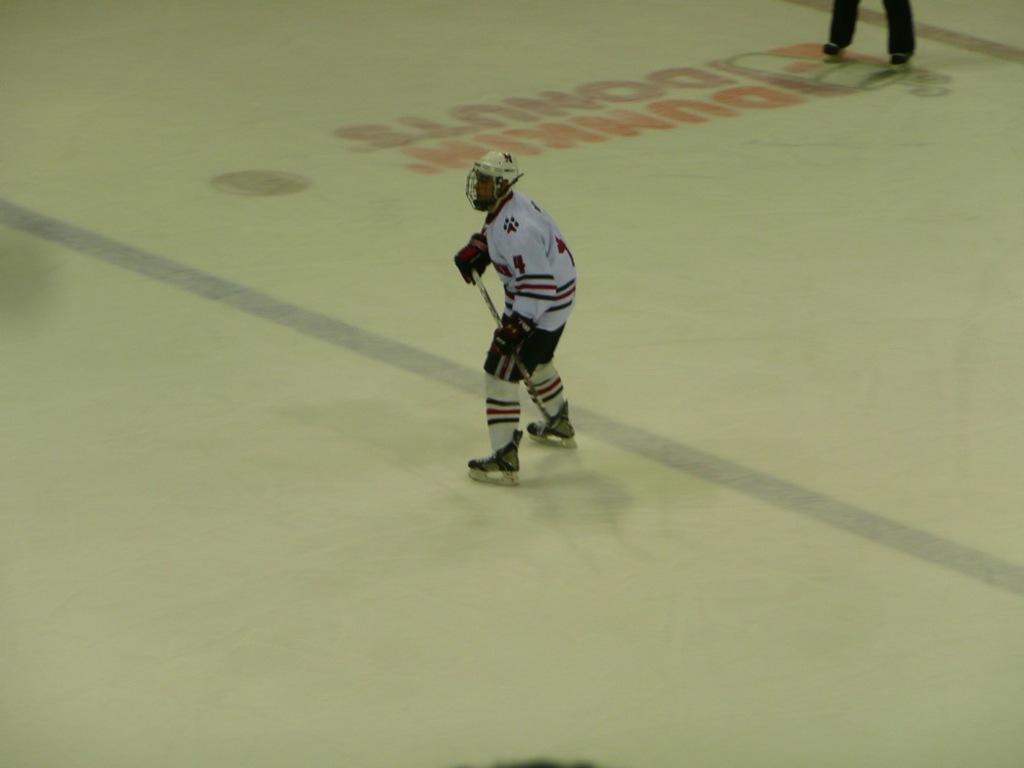Provide a one-sentence caption for the provided image. Dunkin Donuts is a sponsor of the home ice hockey team. 